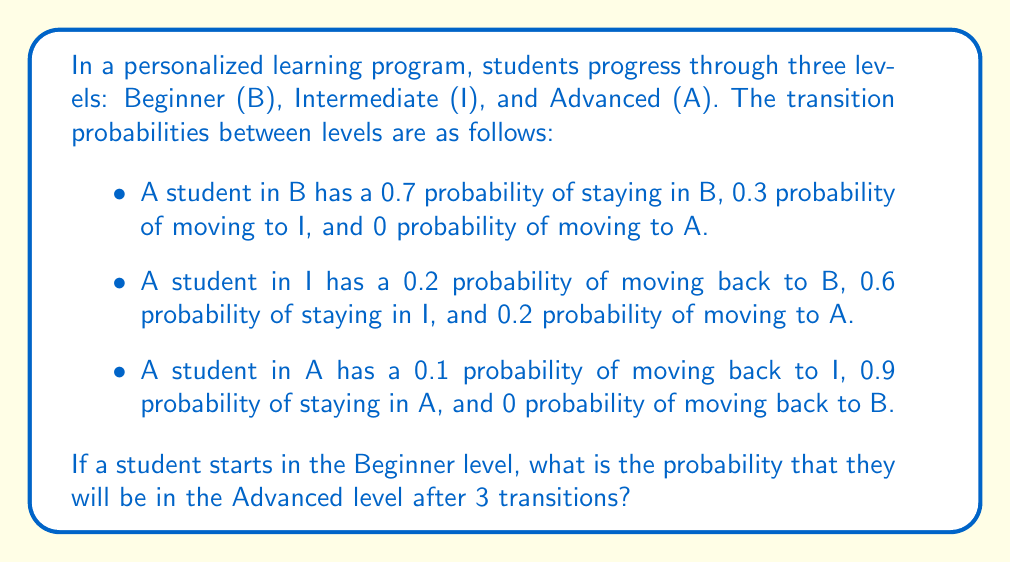Can you solve this math problem? To solve this problem, we'll use Markov chains and matrix multiplication. Let's follow these steps:

1. First, we need to set up the transition matrix P:

   $$P = \begin{bmatrix}
   0.7 & 0.3 & 0 \\
   0.2 & 0.6 & 0.2 \\
   0 & 0.1 & 0.9
   \end{bmatrix}$$

2. The initial state vector, starting from Beginner, is:

   $$v_0 = \begin{bmatrix} 1 \\ 0 \\ 0 \end{bmatrix}$$

3. To find the state after 3 transitions, we need to calculate $P^3 \cdot v_0$

4. Let's calculate $P^3$:

   $$P^2 = P \cdot P = \begin{bmatrix}
   0.55 & 0.39 & 0.06 \\
   0.26 & 0.54 & 0.20 \\
   0.02 & 0.13 & 0.85
   \end{bmatrix}$$

   $$P^3 = P^2 \cdot P = \begin{bmatrix}
   0.449 & 0.417 & 0.134 \\
   0.284 & 0.482 & 0.234 \\
   0.038 & 0.157 & 0.805
   \end{bmatrix}$$

5. Now, we multiply $P^3$ by $v_0$:

   $$P^3 \cdot v_0 = \begin{bmatrix}
   0.449 & 0.417 & 0.134 \\
   0.284 & 0.482 & 0.234 \\
   0.038 & 0.157 & 0.805
   \end{bmatrix} \cdot \begin{bmatrix} 1 \\ 0 \\ 0 \end{bmatrix} = \begin{bmatrix} 0.449 \\ 0.284 \\ 0.038 \end{bmatrix}$$

6. The probability of being in the Advanced level after 3 transitions is the third element of this resulting vector.
Answer: 0.038 